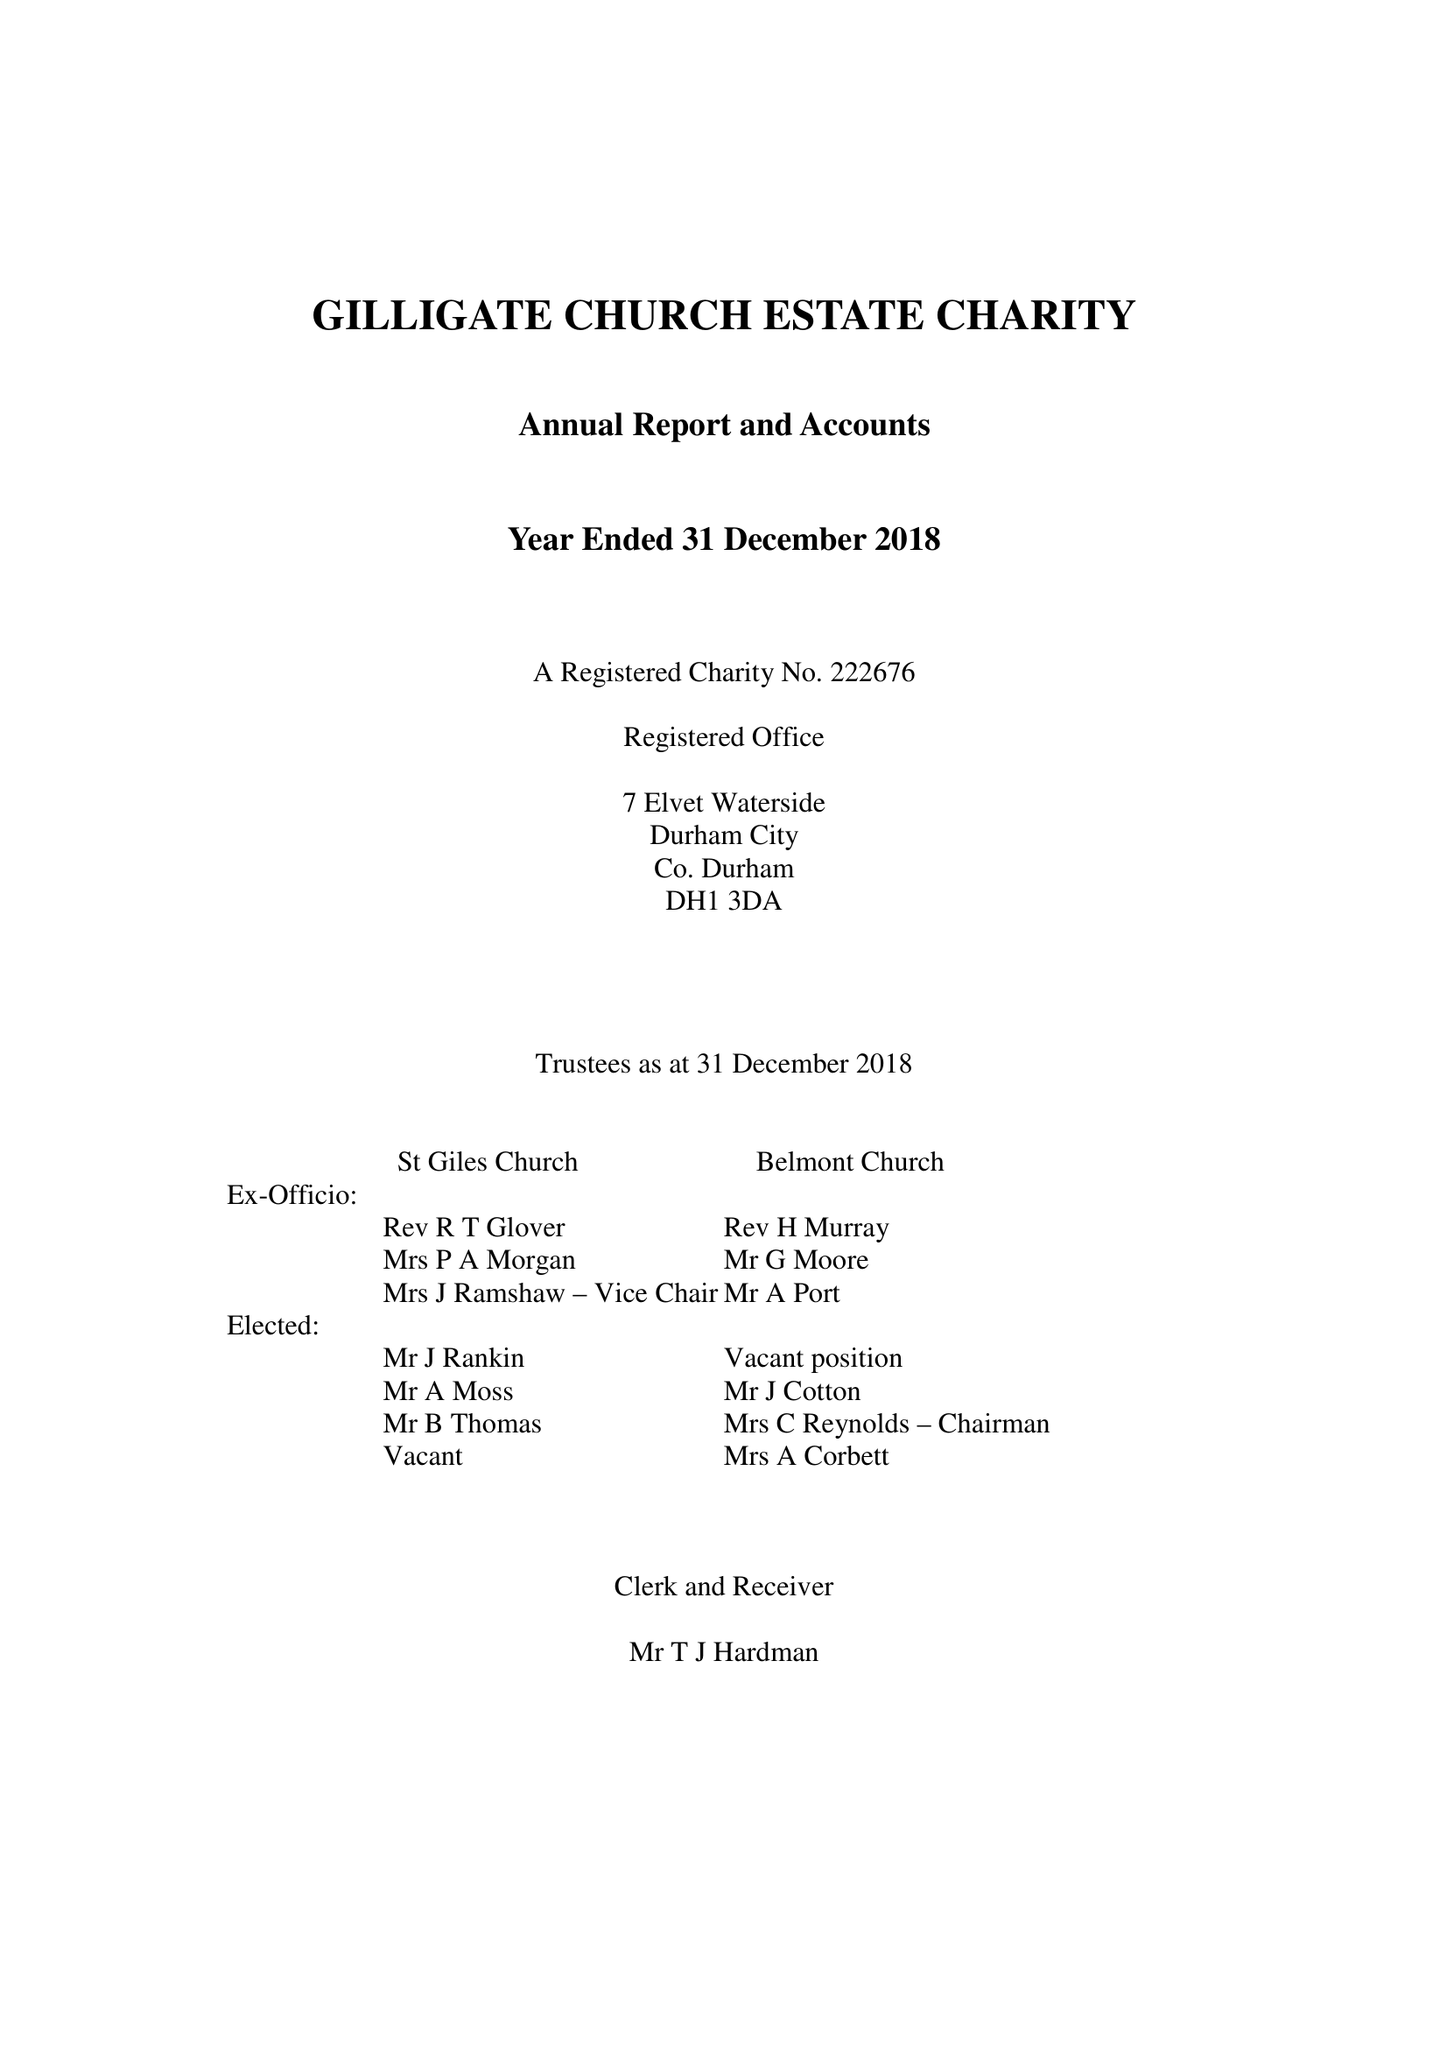What is the value for the address__street_line?
Answer the question using a single word or phrase. 7 ELVET WATERSIDE 